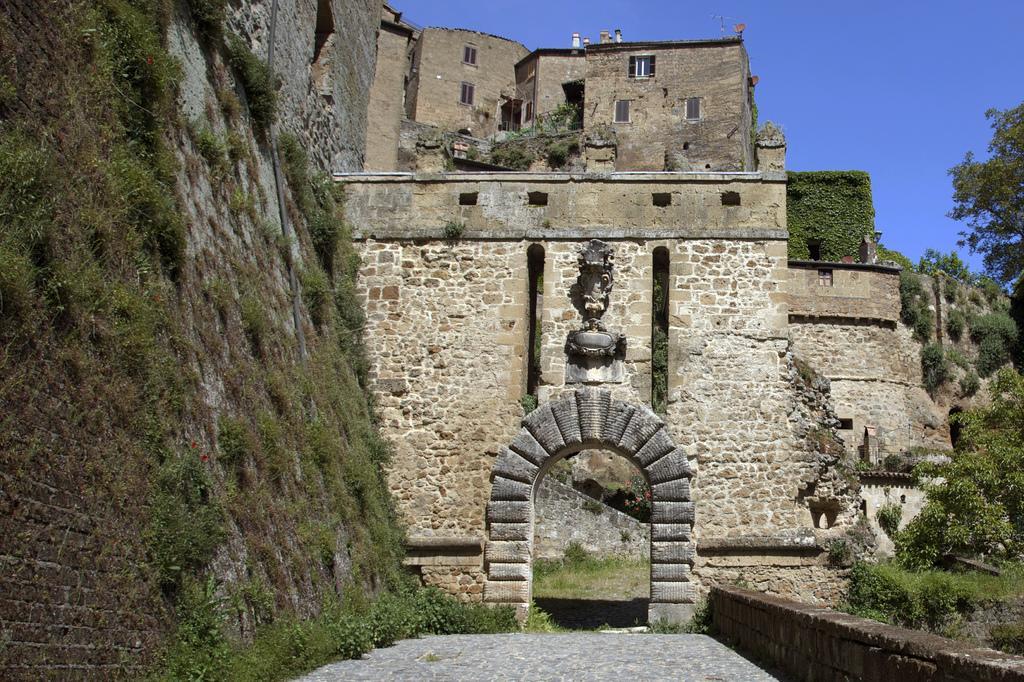Please provide a concise description of this image. In this picture I can see an arch in the middle, in the background it looks like a fort. On the right side there are trees, at the top I can see the sky. 